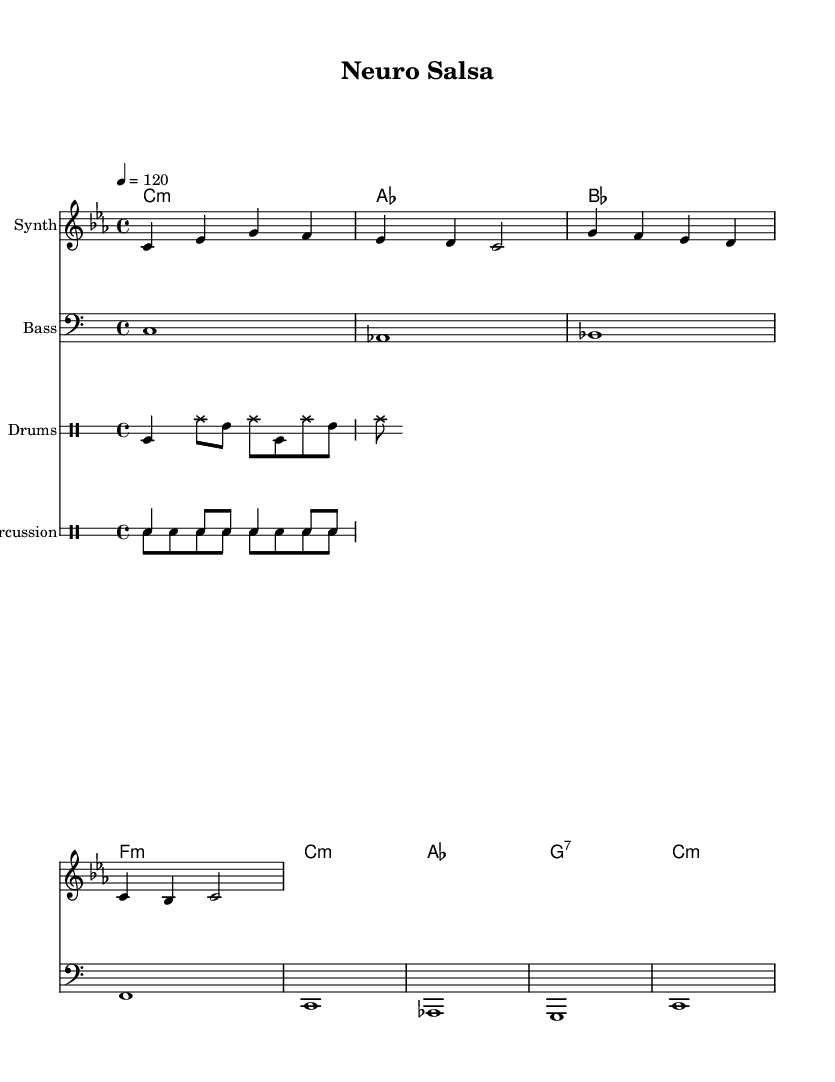What is the key signature of this music? The key signature indicates C minor, which has three flats (B♭, E♭, and A♭).
Answer: C minor What is the time signature of this music? The time signature is located at the beginning of the score and shows 4/4, which means four beats per measure.
Answer: 4/4 What is the tempo marking in this music? The tempo marking is written as "4 = 120" which indicates the quarter note gets 120 beats per minute.
Answer: 120 How many bars are in the melody? By counting the measures in the melody line, there are four measures total.
Answer: 4 What type of percussion instruments are used in this score? The score includes conga and bongo drums, which are traditional Latin percussion instruments.
Answer: Conga and bongo What is the root chord of the first measure in the harmony? The first measure indicates a C minor chord, which is the root chord for that measure.
Answer: C:m How is the bass line structured in this score? The bass line corresponds to the chords and consists of a series of root notes aligned with the harmony, written in bass clef.
Answer: Root notes aligned with harmony 